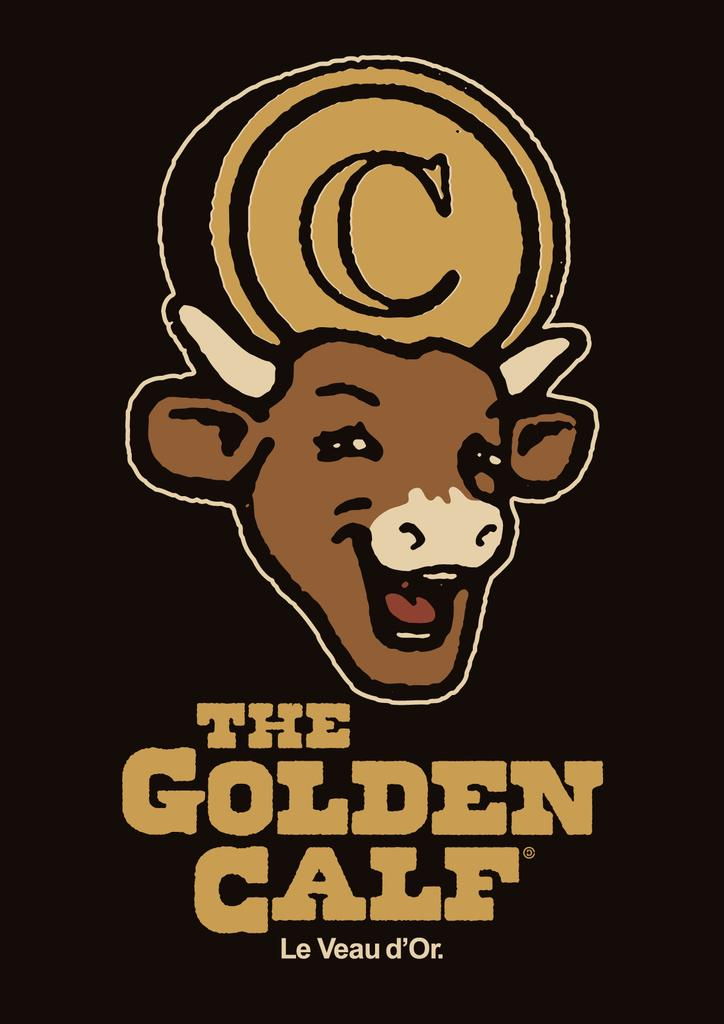What is the main subject of the image? The main subject of the image is an advertisement. What can be seen in the advertisement? The advertisement contains a picture of a calf. What type of crime is being committed in the image? There is no crime being committed in the image; it features an advertisement with a picture of a calf. What grade is the calf in the image? The image does not indicate a grade for the calf, as it is a picture in an advertisement and not a school setting. 